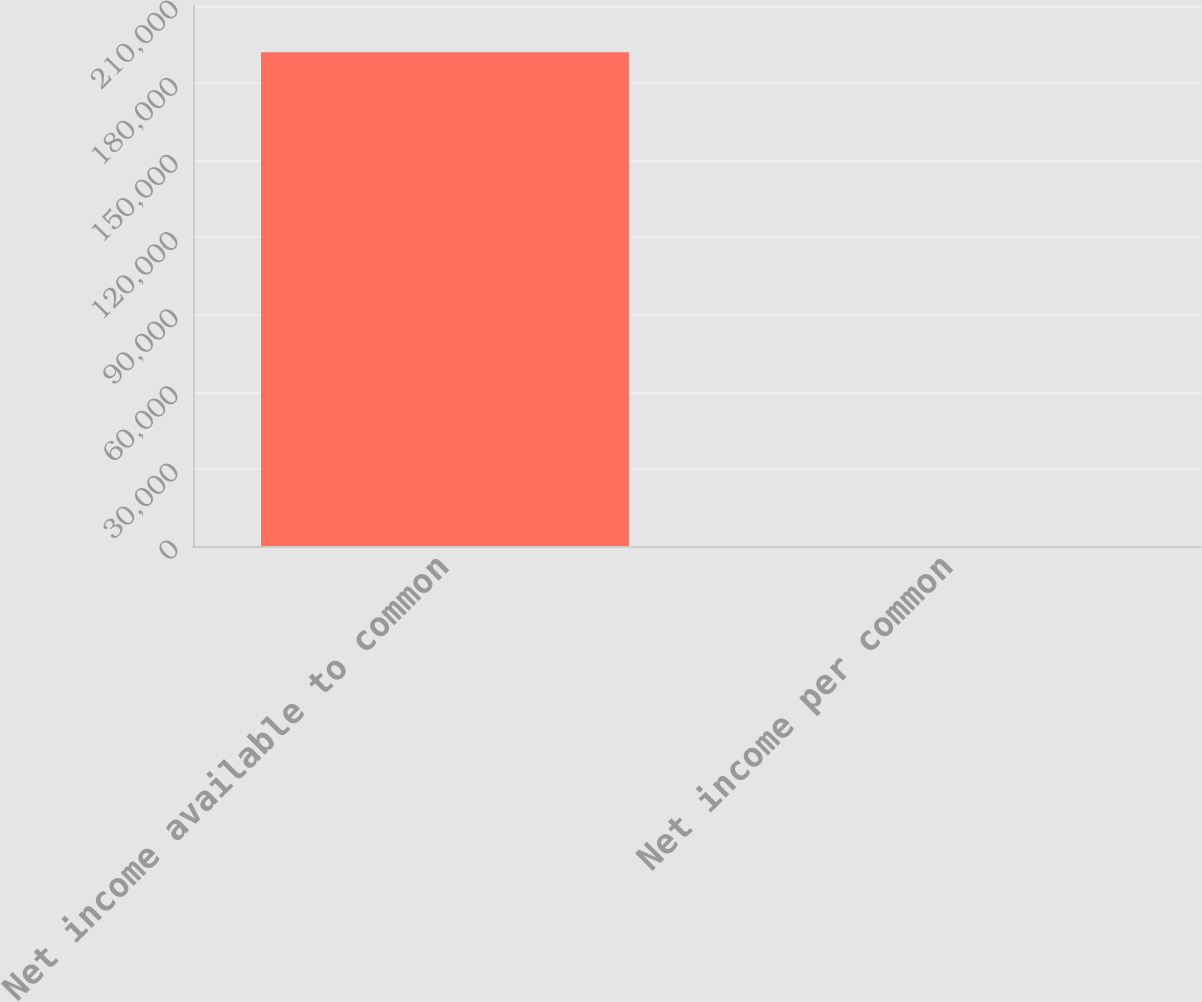Convert chart. <chart><loc_0><loc_0><loc_500><loc_500><bar_chart><fcel>Net income available to common<fcel>Net income per common<nl><fcel>191973<fcel>2.08<nl></chart> 